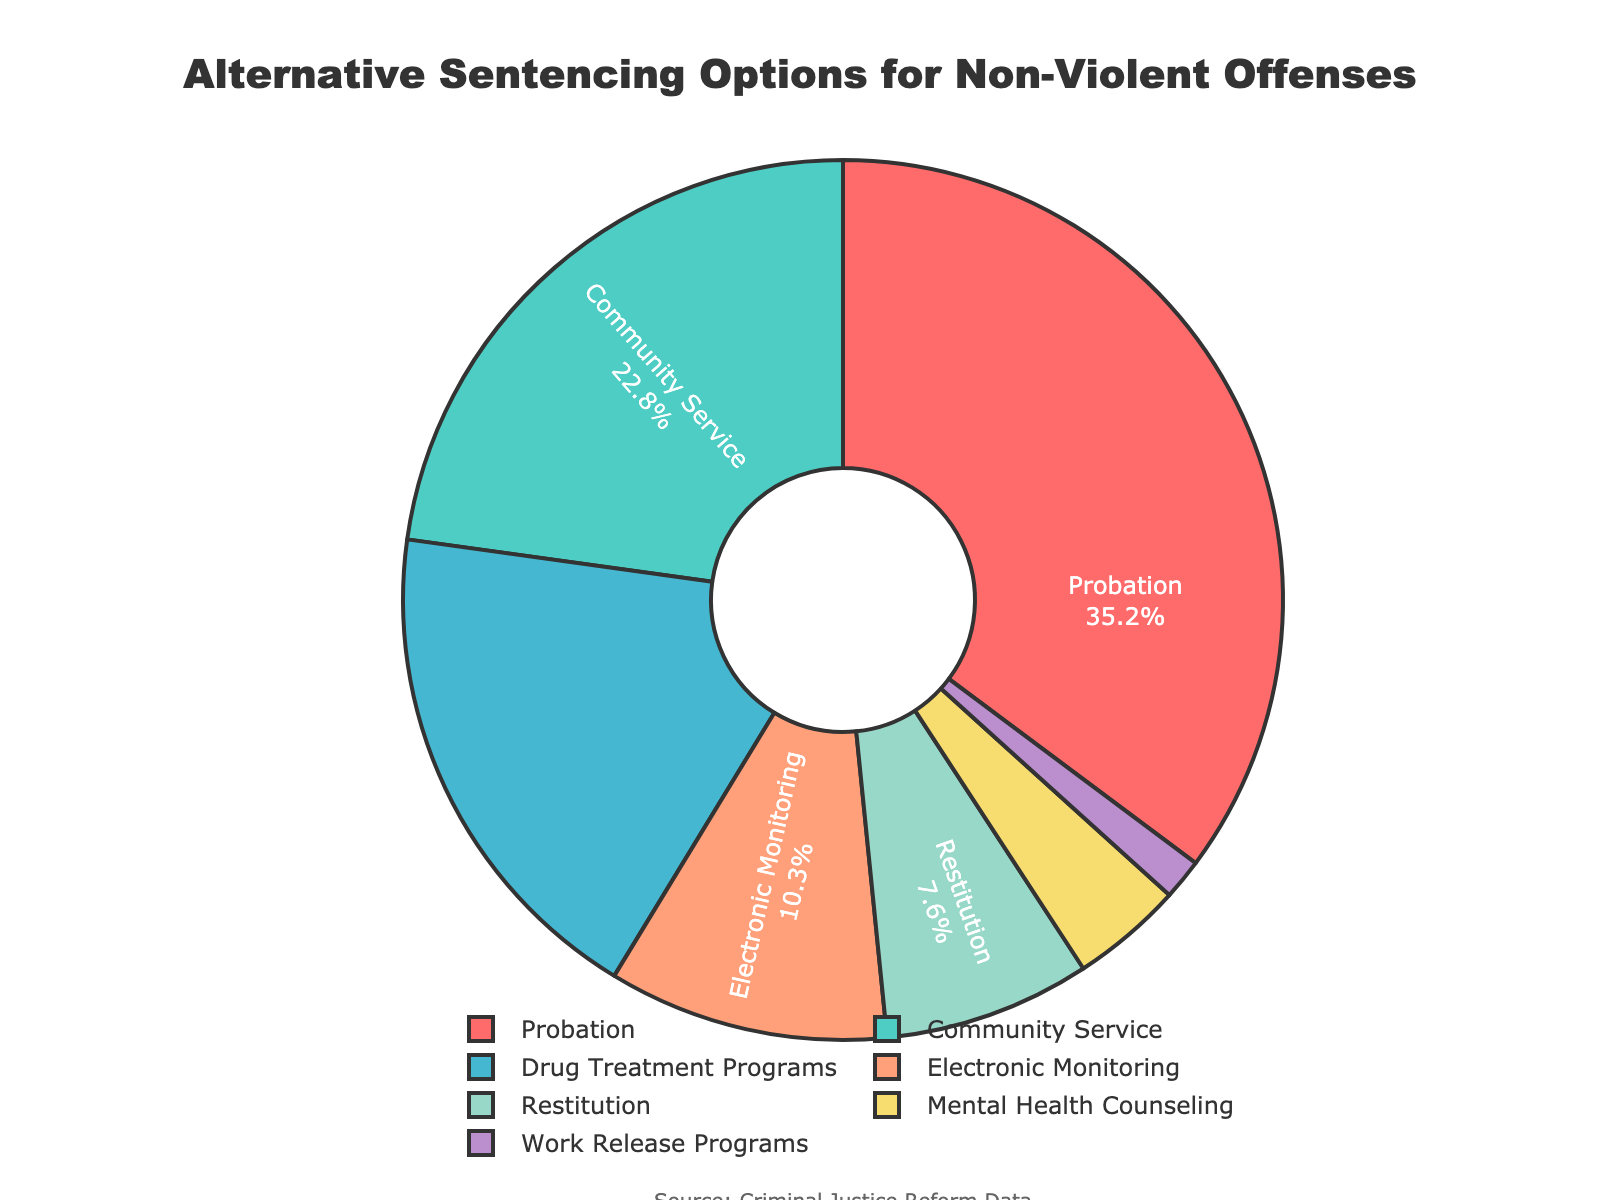What's the largest proportion of alternative sentencing options for non-violent offenses? Look at the pie chart and find the section with the largest percentage. The largest proportion is labeled "Probation" with 35.2%.
Answer: Probation What is the combined percentage of Drug Treatment Programs and Mental Health Counseling? Add the percentages of Drug Treatment Programs (18.5%) and Mental Health Counseling (4.1%) to find the combined total: 18.5 + 4.1 = 22.6%.
Answer: 22.6% Is the percentage of Community Service more or less than the percentage of Electronic Monitoring? Compare the percentages of Community Service (22.8%) and Electronic Monitoring (10.3%). Community Service (22.8%) is more than Electronic Monitoring (10.3%).
Answer: More Which sentencing option has the smallest representation in the chart? Find the section with the smallest percentage, which is "Work Release Programs" with 1.5%.
Answer: Work Release Programs How much more is the percentage of Probation compared to Restitution? Subtract the percentage of Restitution (7.6%) from the percentage of Probation (35.2%): 35.2 - 7.6 = 27.6%.
Answer: 27.6% What proportion of the chart is covered by options related to direct community involvement (Probation and Community Service)? Add the percentages of Probation (35.2%) and Community Service (22.8%) for total community involvement: 35.2 + 22.8 = 58%.
Answer: 58% Which two options together make up more than 30% but less than 50% of the cases? Add different pairs of options to find pairs totaling between 30% and 50%. Drug Treatment Programs (18.5%) + Community Service (22.8%) = 41.3% fits the criteria.
Answer: Drug Treatment Programs and Community Service Are there more cases using Drug Treatment Programs or Electronic Monitoring? Compare the percentages of Drug Treatment Programs (18.5%) and Electronic Monitoring (10.3%). Drug Treatment Programs (18.5%) have a higher percentage.
Answer: Drug Treatment Programs What is the average percentage of all seven alternative sentencing options? Calculate the sum of percentages for all options and then divide by the number of options: (35.2 + 22.8 + 18.5 + 10.3 + 7.6 + 4.1 + 1.5) / 7 = 100 / 7 ≈ 14.29%.
Answer: Approximately 14.29% Is the combined percentage of options involving monitoring (Electronic Monitoring and Probation) greater than 40%? Combine Electronic Monitoring (10.3%) and Probation (35.2%) totals: 10.3 + 35.2 = 45.5%, which is greater than 40%.
Answer: Yes 